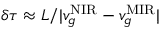Convert formula to latex. <formula><loc_0><loc_0><loc_500><loc_500>\delta \tau \approx L / | v _ { g } ^ { N I R } - v _ { g } ^ { M I R } |</formula> 